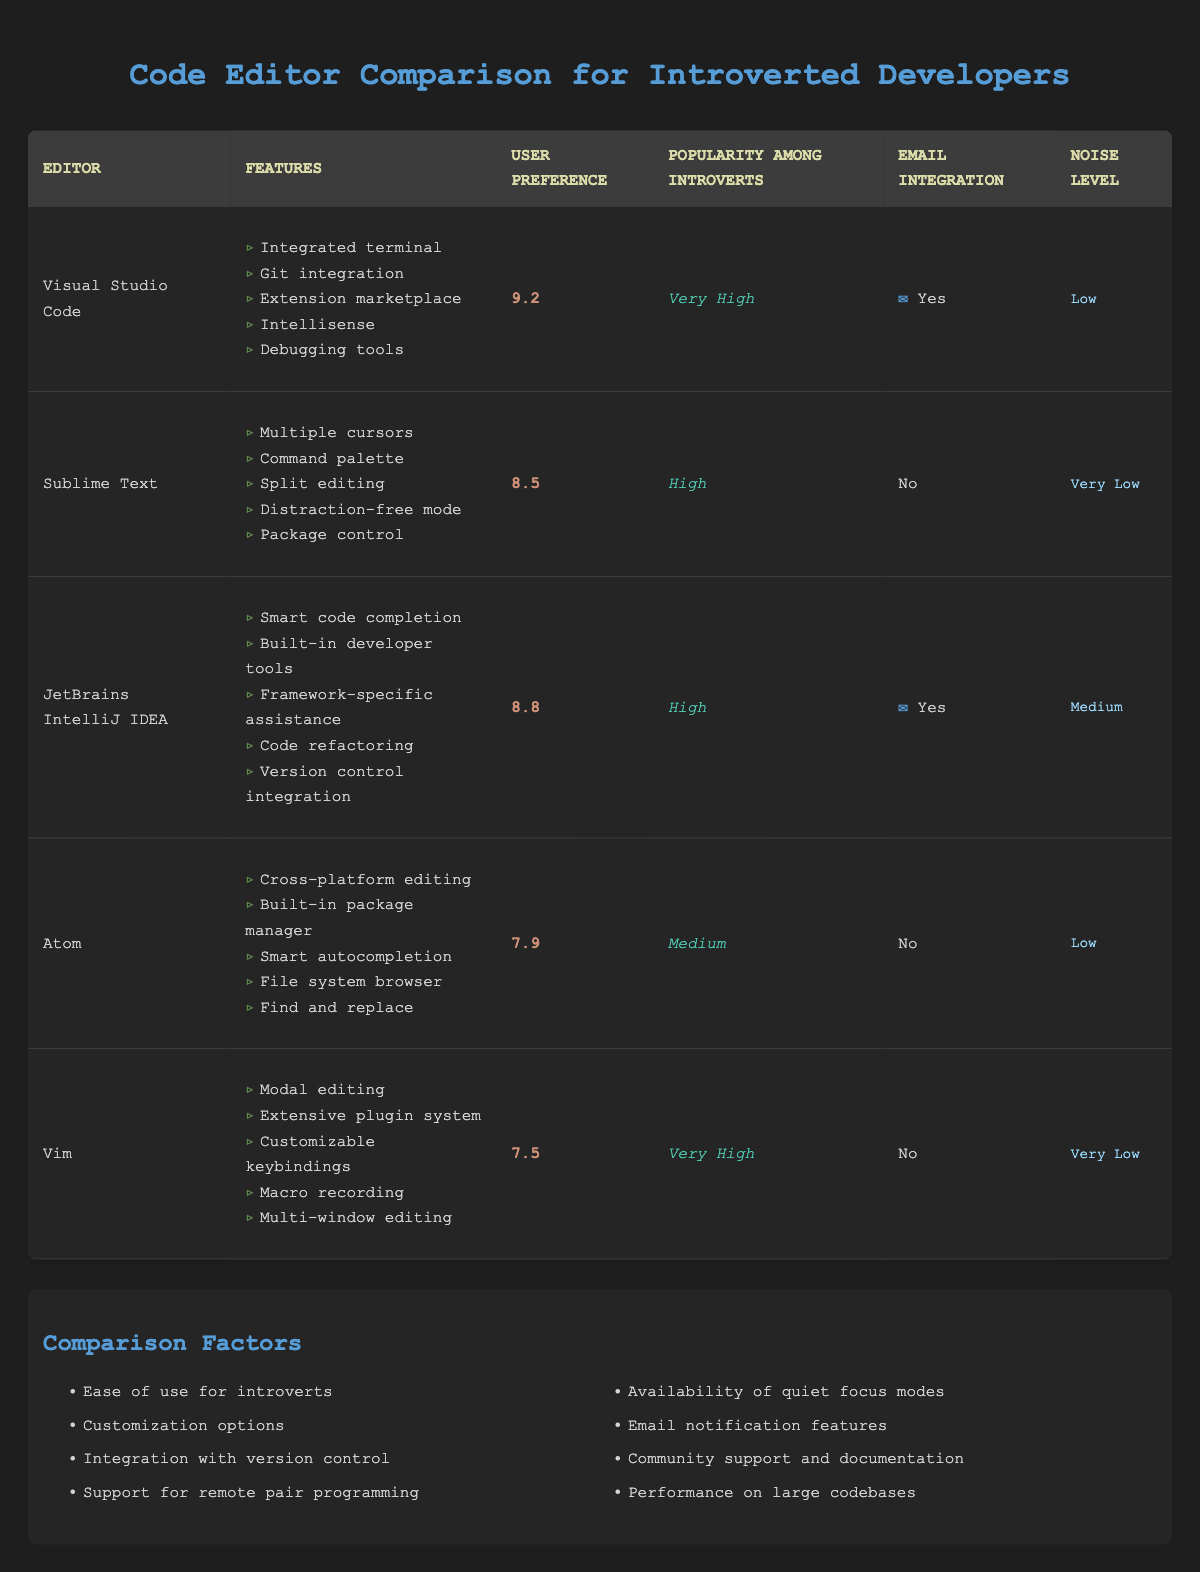What is the user preference rating for Visual Studio Code? The user preference rating for Visual Studio Code is provided in the table. Looking at the "User Preference" column, it shows a value of 9.2.
Answer: 9.2 Which code editor has the highest popularity among introverts? By examining the "Popularity Among Introverts" column, both Visual Studio Code and Vim are marked as "Very High." Therefore, they share the highest popularity rating.
Answer: Visual Studio Code and Vim Does Atom have email integration? The "Email Integration" column for Atom indicates a value of "No," which specifies that Atom does not support email integration.
Answer: No What is the average user preference rating for editors that integrate with email? The editors that integrate with email are Visual Studio Code and JetBrains IntelliJ IDEA, with user preference ratings of 9.2 and 8.8 respectively. Adding these values gives 9.2 + 8.8 = 18, and dividing by 2 provides an average of 9.0.
Answer: 9.0 How many editors have a noise level classified as "Low"? Reviewing the "Noise Level" column in the table, Visual Studio Code, Atom, and Sublime Text have a noise level of "Low." Therefore, there are 3 editors in this category.
Answer: 3 Which editor has the lowest user preference rating and what is it? Checking the "User Preference" column, Vim has a user preference rating of 7.5, which is the lowest among all listed editors.
Answer: Vim; 7.5 Is there a code editor with distraction-free mode among those listed? The "Features" column for Sublime Text includes "Distraction-free mode," confirming that it does have this feature.
Answer: Yes What is the difference in user preference between Atom and JetBrains IntelliJ IDEA? The user preference for Atom is 7.9 and for JetBrains IntelliJ IDEA is 8.8. Calculating the difference, 8.8 - 7.9 equals 0.9.
Answer: 0.9 How many editors among the list have a noise level that is considered "Very Low"? By looking at the "Noise Level" column, Vim and Sublime Text are classified as "Very Low," thus there are 2 editors with this noise level rating.
Answer: 2 What is the highest rated user preference among editors that do not integrate with email? The editors that do not integrate with email are Sublime Text, Atom, and Vim, with user preference ratings of 8.5, 7.9, and 7.5. The highest rating among these is 8.5, which belongs to Sublime Text.
Answer: Sublime Text; 8.5 